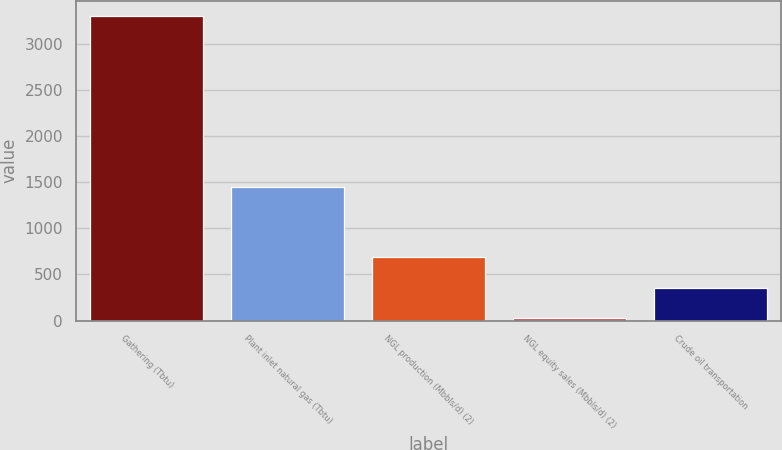Convert chart to OTSL. <chart><loc_0><loc_0><loc_500><loc_500><bar_chart><fcel>Gathering (Tbtu)<fcel>Plant inlet natural gas (Tbtu)<fcel>NGL production (Mbbls/d) (2)<fcel>NGL equity sales (Mbbls/d) (2)<fcel>Crude oil transportation<nl><fcel>3298<fcel>1448<fcel>684.4<fcel>31<fcel>357.7<nl></chart> 